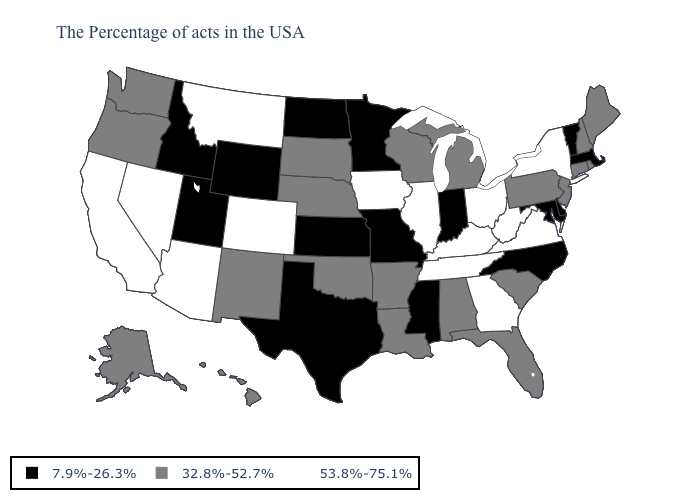What is the value of Colorado?
Quick response, please. 53.8%-75.1%. Name the states that have a value in the range 7.9%-26.3%?
Give a very brief answer. Massachusetts, Vermont, Delaware, Maryland, North Carolina, Indiana, Mississippi, Missouri, Minnesota, Kansas, Texas, North Dakota, Wyoming, Utah, Idaho. What is the value of Utah?
Answer briefly. 7.9%-26.3%. Does Nevada have the highest value in the West?
Keep it brief. Yes. Which states have the lowest value in the West?
Quick response, please. Wyoming, Utah, Idaho. Name the states that have a value in the range 53.8%-75.1%?
Answer briefly. New York, Virginia, West Virginia, Ohio, Georgia, Kentucky, Tennessee, Illinois, Iowa, Colorado, Montana, Arizona, Nevada, California. Among the states that border Washington , does Oregon have the lowest value?
Give a very brief answer. No. Does Kentucky have the lowest value in the USA?
Be succinct. No. What is the highest value in states that border Illinois?
Give a very brief answer. 53.8%-75.1%. Among the states that border New Jersey , does Delaware have the lowest value?
Keep it brief. Yes. Among the states that border Wyoming , does Montana have the highest value?
Keep it brief. Yes. Name the states that have a value in the range 32.8%-52.7%?
Be succinct. Maine, Rhode Island, New Hampshire, Connecticut, New Jersey, Pennsylvania, South Carolina, Florida, Michigan, Alabama, Wisconsin, Louisiana, Arkansas, Nebraska, Oklahoma, South Dakota, New Mexico, Washington, Oregon, Alaska, Hawaii. Among the states that border Rhode Island , which have the highest value?
Short answer required. Connecticut. Which states have the lowest value in the USA?
Keep it brief. Massachusetts, Vermont, Delaware, Maryland, North Carolina, Indiana, Mississippi, Missouri, Minnesota, Kansas, Texas, North Dakota, Wyoming, Utah, Idaho. Does Virginia have the lowest value in the South?
Short answer required. No. 